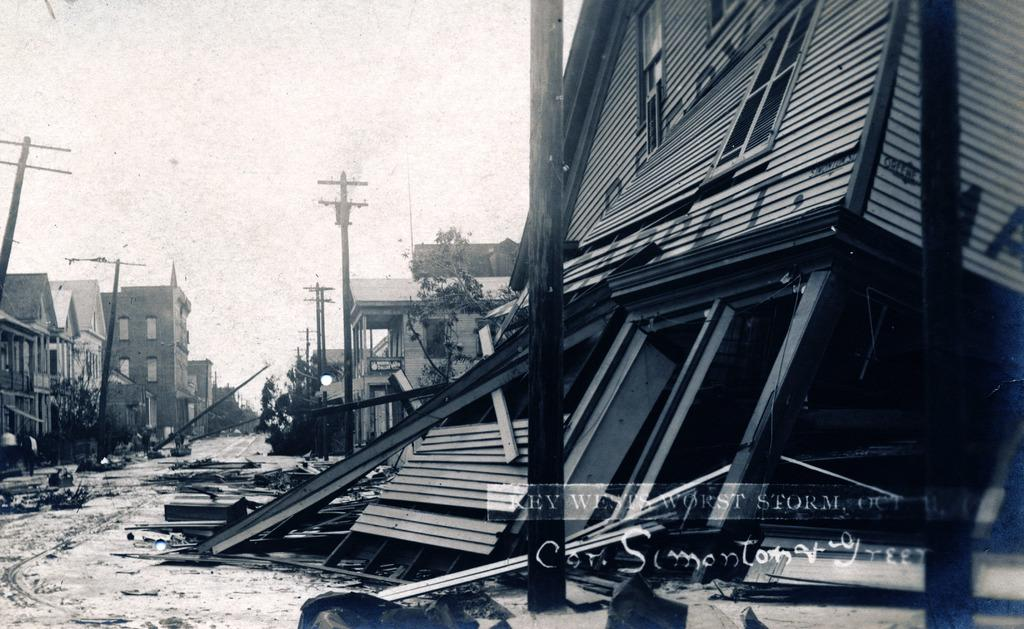What is the color scheme of the image? The image is black and white. What type of structures can be seen in the image? There are buildings in the image. What other natural elements are present in the image? There are trees in the image. What are the vertical structures with wires in the image? There are current poles in the image. What part of the sky is visible in the image? The sky is visible in the image. How many lizards can be seen crawling on the buildings in the image? There are no lizards present in the image; it features buildings, trees, current poles, and the sky. What type of transportation can be seen moving through the image? There are no trains or any other form of transportation visible in the image. 